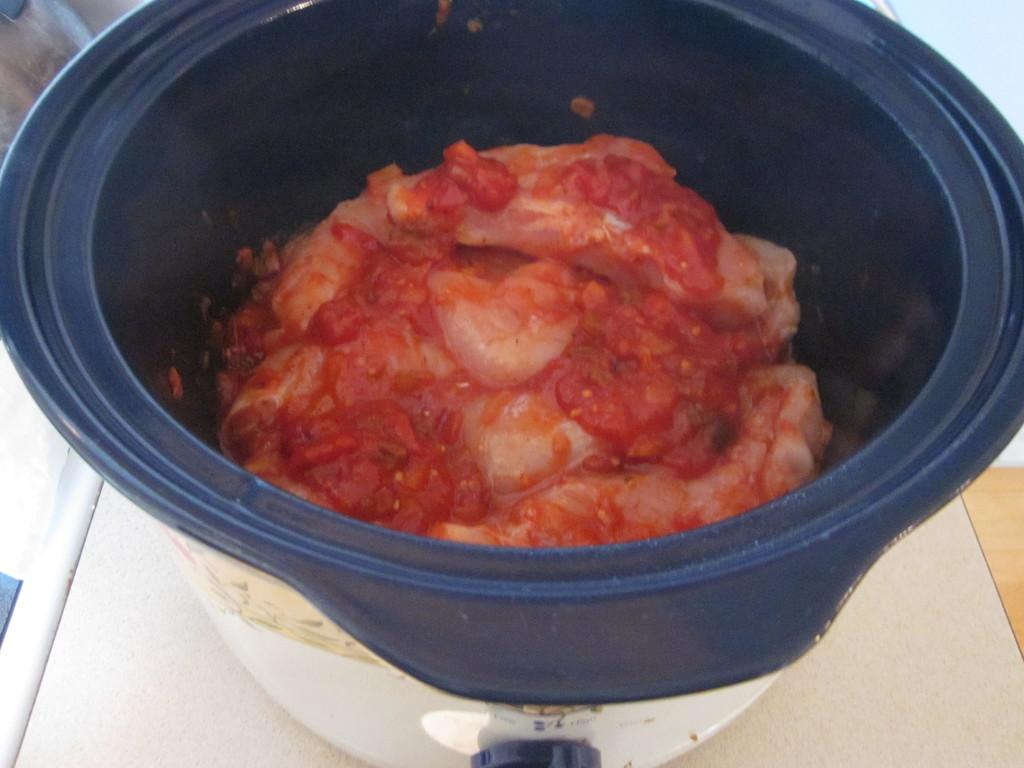What is present in the image? There is a container in the image. What is inside the container? There is a food item in the container. What is the taste of the cheese in the image? There is no cheese present in the image, so it is not possible to determine its taste. 